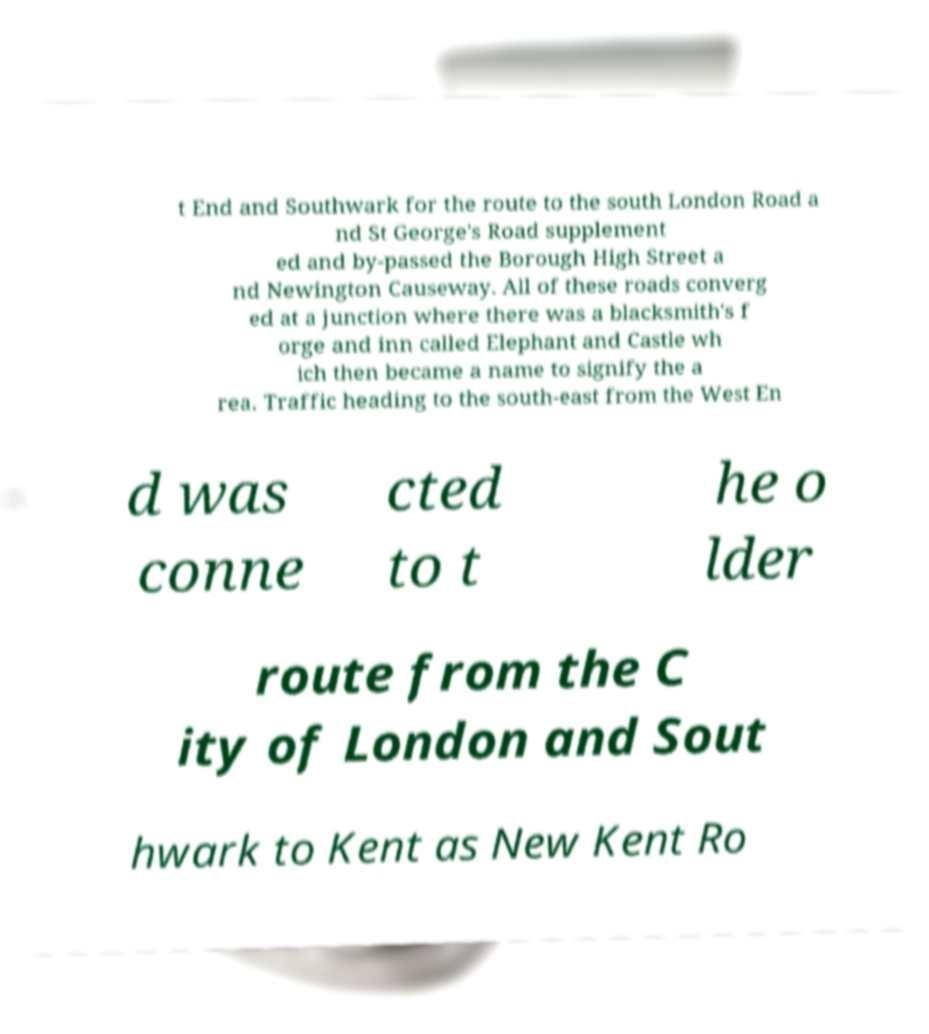There's text embedded in this image that I need extracted. Can you transcribe it verbatim? t End and Southwark for the route to the south London Road a nd St George's Road supplement ed and by-passed the Borough High Street a nd Newington Causeway. All of these roads converg ed at a junction where there was a blacksmith's f orge and inn called Elephant and Castle wh ich then became a name to signify the a rea. Traffic heading to the south-east from the West En d was conne cted to t he o lder route from the C ity of London and Sout hwark to Kent as New Kent Ro 